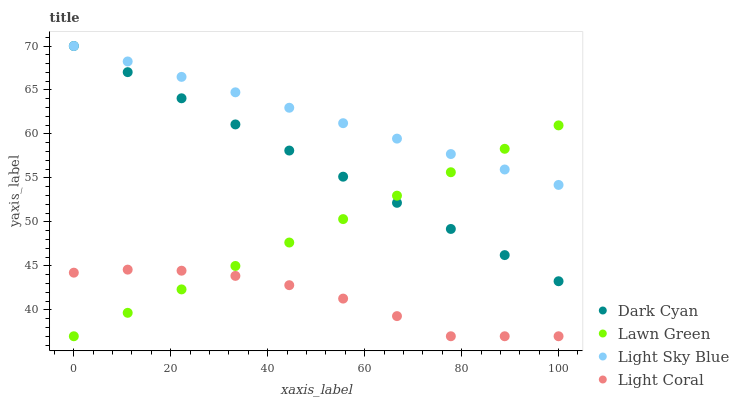Does Light Coral have the minimum area under the curve?
Answer yes or no. Yes. Does Light Sky Blue have the maximum area under the curve?
Answer yes or no. Yes. Does Lawn Green have the minimum area under the curve?
Answer yes or no. No. Does Lawn Green have the maximum area under the curve?
Answer yes or no. No. Is Dark Cyan the smoothest?
Answer yes or no. Yes. Is Light Coral the roughest?
Answer yes or no. Yes. Is Lawn Green the smoothest?
Answer yes or no. No. Is Lawn Green the roughest?
Answer yes or no. No. Does Lawn Green have the lowest value?
Answer yes or no. Yes. Does Light Sky Blue have the lowest value?
Answer yes or no. No. Does Light Sky Blue have the highest value?
Answer yes or no. Yes. Does Lawn Green have the highest value?
Answer yes or no. No. Is Light Coral less than Light Sky Blue?
Answer yes or no. Yes. Is Dark Cyan greater than Light Coral?
Answer yes or no. Yes. Does Lawn Green intersect Light Sky Blue?
Answer yes or no. Yes. Is Lawn Green less than Light Sky Blue?
Answer yes or no. No. Is Lawn Green greater than Light Sky Blue?
Answer yes or no. No. Does Light Coral intersect Light Sky Blue?
Answer yes or no. No. 